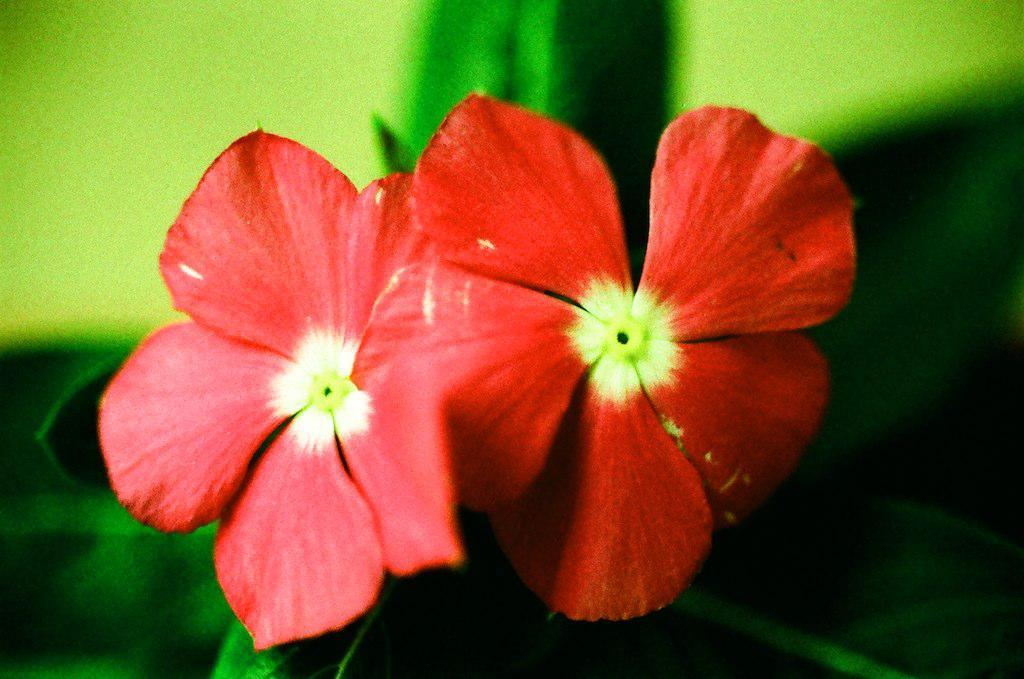How many flowers are present in the image? There are two flowers in the image. Can you describe the background of the image? The background of the image is blurred. Where is the kitten located in the image? There is no kitten present in the image. What route do the flowers follow in the image? The flowers do not follow a route, as they are stationary in the image. What type of glove is visible in the image? There is no glove present in the image. 